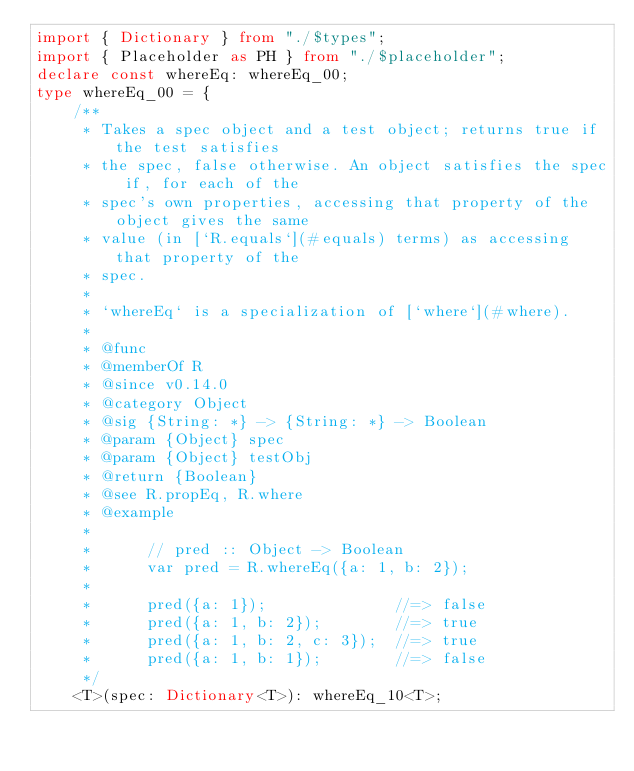Convert code to text. <code><loc_0><loc_0><loc_500><loc_500><_TypeScript_>import { Dictionary } from "./$types";
import { Placeholder as PH } from "./$placeholder";
declare const whereEq: whereEq_00;
type whereEq_00 = {
    /**
     * Takes a spec object and a test object; returns true if the test satisfies
     * the spec, false otherwise. An object satisfies the spec if, for each of the
     * spec's own properties, accessing that property of the object gives the same
     * value (in [`R.equals`](#equals) terms) as accessing that property of the
     * spec.
     *
     * `whereEq` is a specialization of [`where`](#where).
     *
     * @func
     * @memberOf R
     * @since v0.14.0
     * @category Object
     * @sig {String: *} -> {String: *} -> Boolean
     * @param {Object} spec
     * @param {Object} testObj
     * @return {Boolean}
     * @see R.propEq, R.where
     * @example
     *
     *      // pred :: Object -> Boolean
     *      var pred = R.whereEq({a: 1, b: 2});
     *
     *      pred({a: 1});              //=> false
     *      pred({a: 1, b: 2});        //=> true
     *      pred({a: 1, b: 2, c: 3});  //=> true
     *      pred({a: 1, b: 1});        //=> false
     */
    <T>(spec: Dictionary<T>): whereEq_10<T>;</code> 